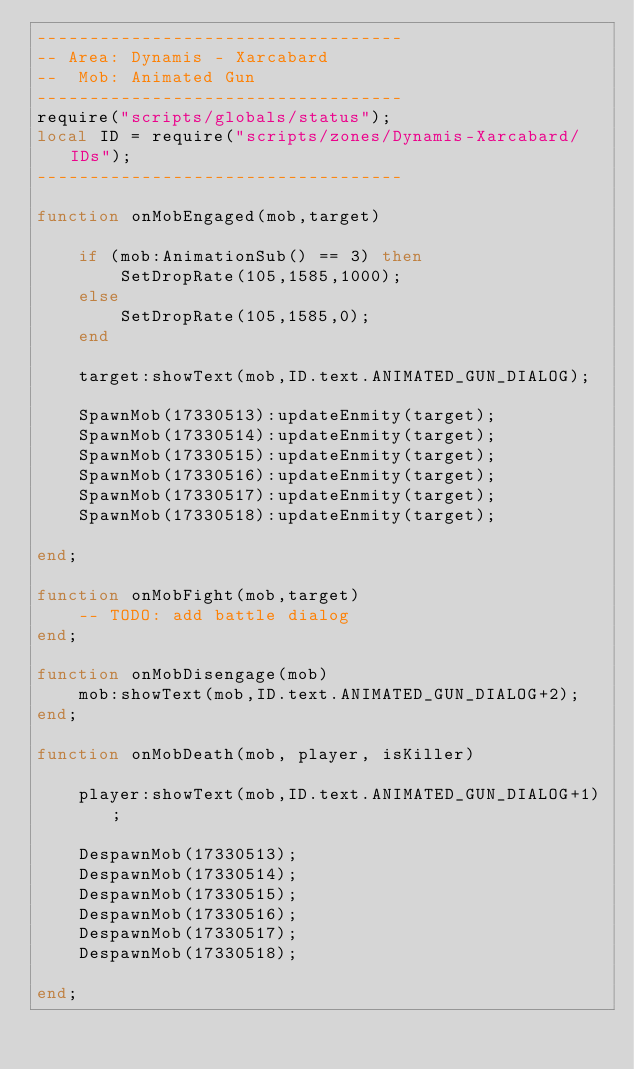<code> <loc_0><loc_0><loc_500><loc_500><_Lua_>-----------------------------------
-- Area: Dynamis - Xarcabard
--  Mob: Animated Gun
-----------------------------------
require("scripts/globals/status");
local ID = require("scripts/zones/Dynamis-Xarcabard/IDs");
-----------------------------------

function onMobEngaged(mob,target)

    if (mob:AnimationSub() == 3) then
        SetDropRate(105,1585,1000);
    else
        SetDropRate(105,1585,0);
    end

    target:showText(mob,ID.text.ANIMATED_GUN_DIALOG);

    SpawnMob(17330513):updateEnmity(target);
    SpawnMob(17330514):updateEnmity(target);
    SpawnMob(17330515):updateEnmity(target);
    SpawnMob(17330516):updateEnmity(target);
    SpawnMob(17330517):updateEnmity(target);
    SpawnMob(17330518):updateEnmity(target);

end;

function onMobFight(mob,target)
    -- TODO: add battle dialog
end;

function onMobDisengage(mob)
    mob:showText(mob,ID.text.ANIMATED_GUN_DIALOG+2);
end;

function onMobDeath(mob, player, isKiller)

    player:showText(mob,ID.text.ANIMATED_GUN_DIALOG+1);

    DespawnMob(17330513);
    DespawnMob(17330514);
    DespawnMob(17330515);
    DespawnMob(17330516);
    DespawnMob(17330517);
    DespawnMob(17330518);

end;</code> 